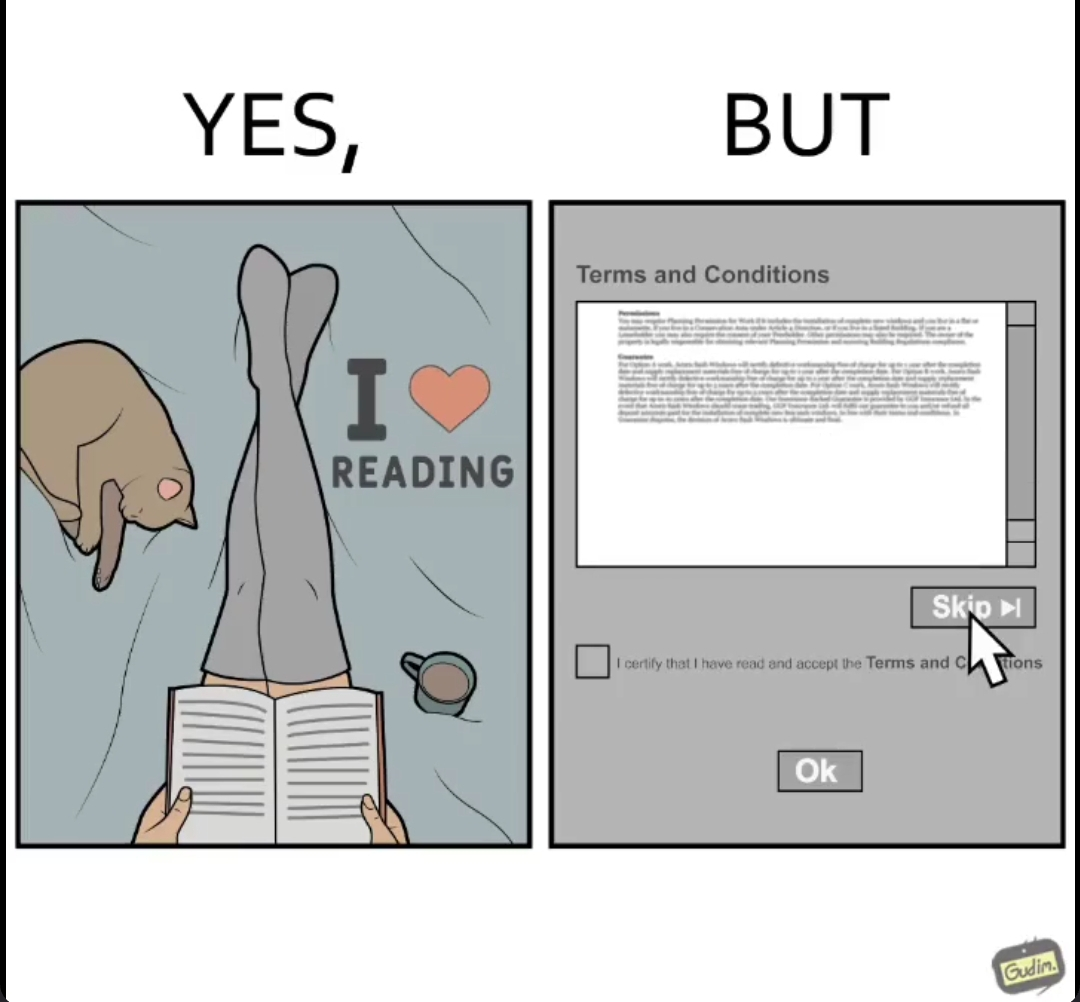Is this a satirical image? Yes, this image is satirical. 